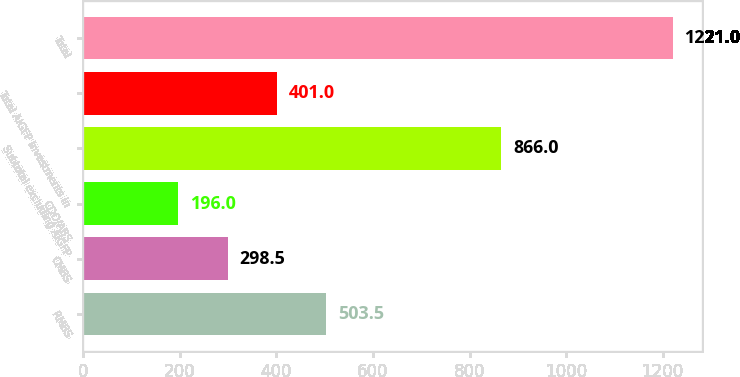Convert chart. <chart><loc_0><loc_0><loc_500><loc_500><bar_chart><fcel>RMBS<fcel>CMBS<fcel>CDO/ABS<fcel>Subtotal excluding AIGFP<fcel>Total AIGFP investments in<fcel>Total<nl><fcel>503.5<fcel>298.5<fcel>196<fcel>866<fcel>401<fcel>1221<nl></chart> 